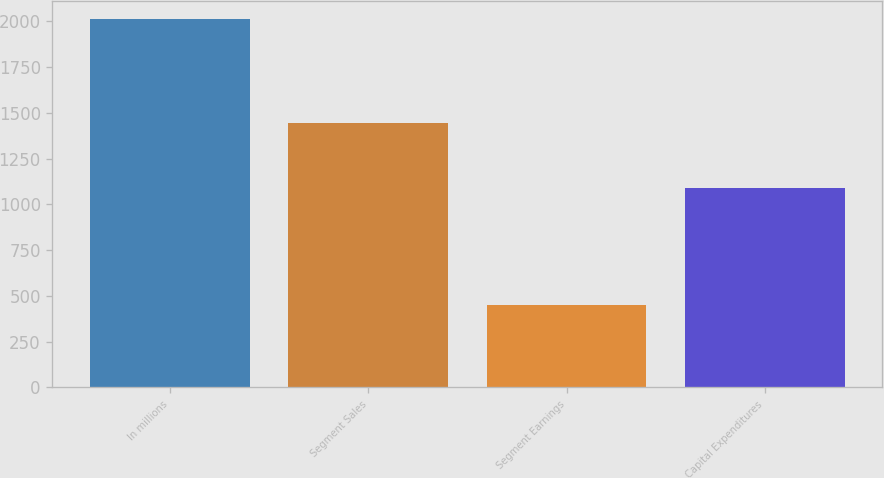<chart> <loc_0><loc_0><loc_500><loc_500><bar_chart><fcel>In millions<fcel>Segment Sales<fcel>Segment Earnings<fcel>Capital Expenditures<nl><fcel>2011<fcel>1447<fcel>448<fcel>1089<nl></chart> 